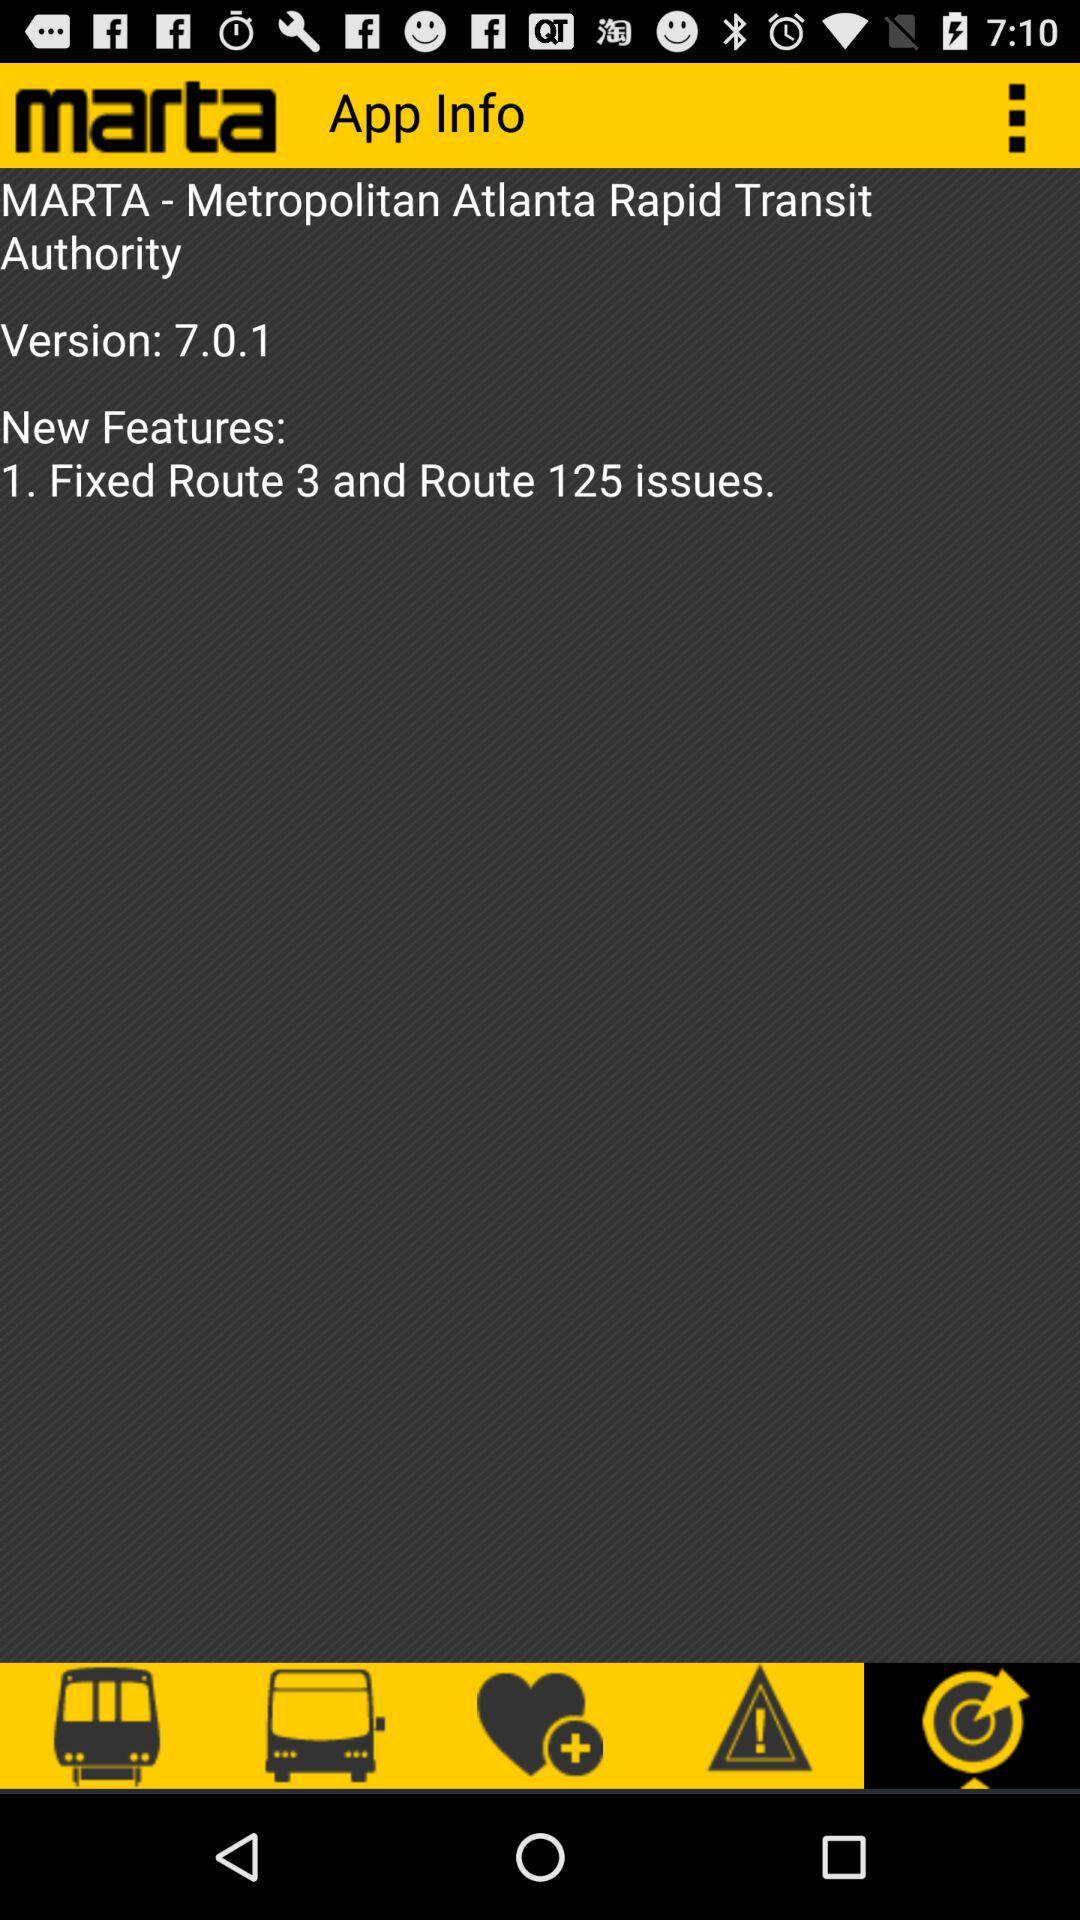What are the new features of "MARTA"? The new feature is "Fixed Route 3 and Route 125 issues". 